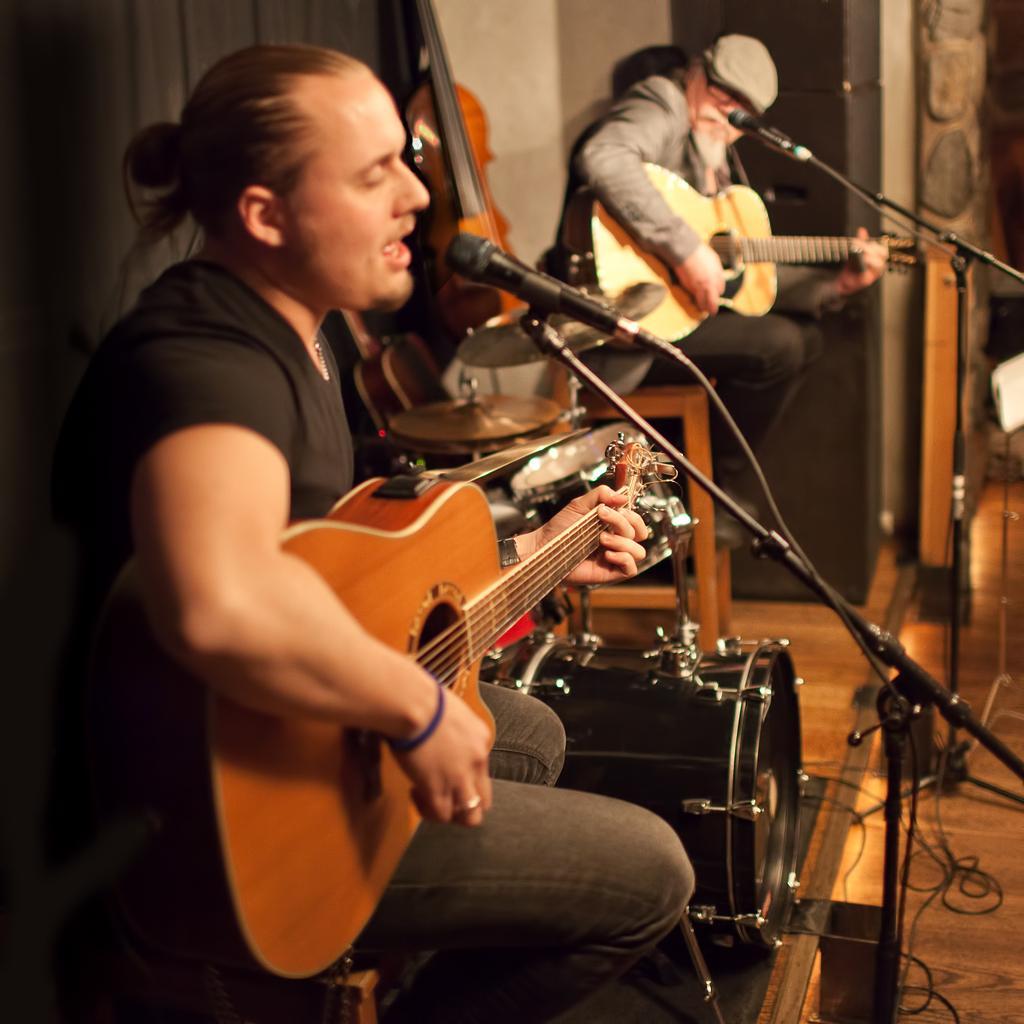In one or two sentences, can you explain what this image depicts? In this picture one person is sitting here and his just singing with the microphone and he is playing a guitar and then other person is sitting beside on the table and he is also playing a guitar he also have the microphone and there are some my musical instruments in between them. 